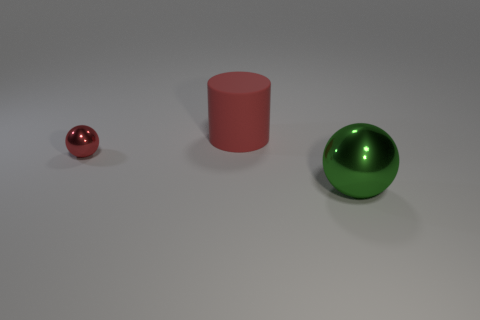How do the objects relate to each other in terms of positioning? The objects are placed at varying distances from the viewer, creating a sense of depth. From left to right, they increase in size, which may enhance the perspective. The arrangement might suggest a gradual progression or escalation in terms of size, and the spacing between them offers a clean, uncluttered view, allowing each object to be appreciated independently. 